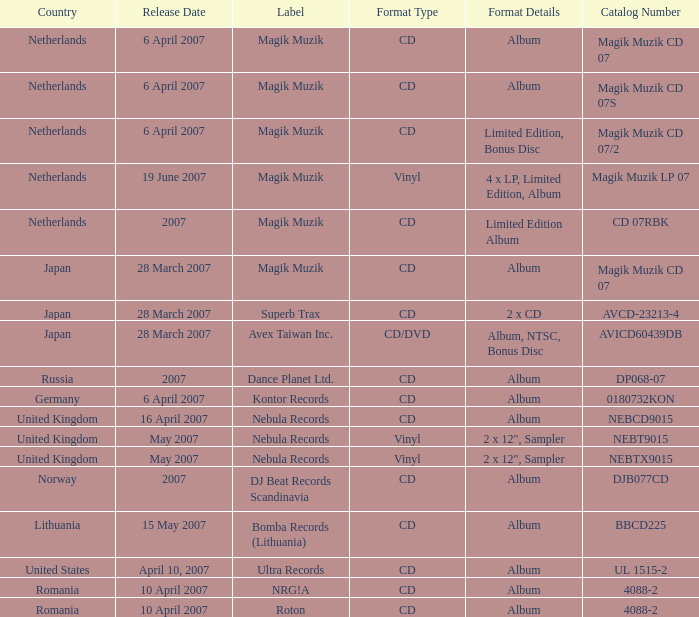From which region is the album with release date of 19 June 2007? Netherlands. 